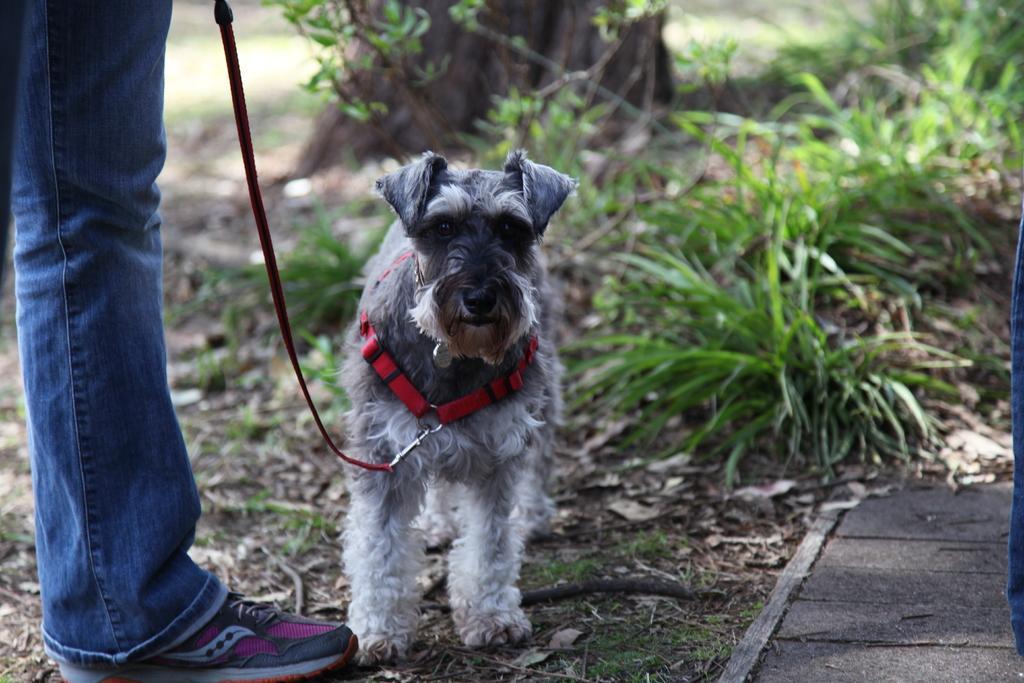In one or two sentences, can you explain what this image depicts? In this picture we can see the leg of a person. We can see a dog. There is a belt around its neck. We can see another belt attached to a hook. We can see dried leaves and twigs on the ground. Background portion of the picture is blurred. We can see plants and grass. 